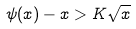Convert formula to latex. <formula><loc_0><loc_0><loc_500><loc_500>\psi ( x ) - x > K \sqrt { x }</formula> 